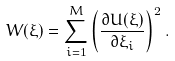<formula> <loc_0><loc_0><loc_500><loc_500>W ( \xi ) = \sum _ { i = 1 } ^ { M } \left ( \frac { \partial U ( \xi ) } { \partial \xi _ { i } } \right ) ^ { 2 } .</formula> 